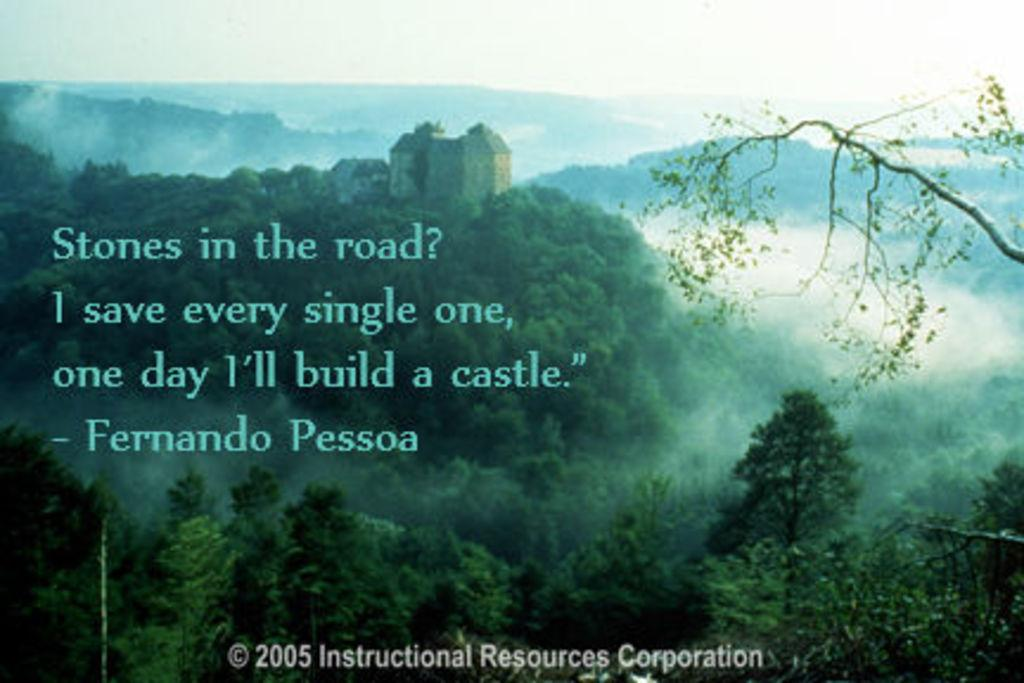What is the main subject of the image? The main subject of the image is a picture. What activities or objects are depicted in the picture? The picture contains ski, hills, buildings, and trees. Is there any text present in the picture? Yes, there is some text in the picture. What type of blade can be seen in the picture? There is no blade present in the picture; it contains ski, hills, buildings, and trees. What game is being played in the picture? There is no game being played in the picture; it depicts ski, hills, buildings, and trees. 